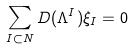Convert formula to latex. <formula><loc_0><loc_0><loc_500><loc_500>\sum _ { I \subset N } D ( \Lambda ^ { I } ) \xi _ { I } = 0</formula> 